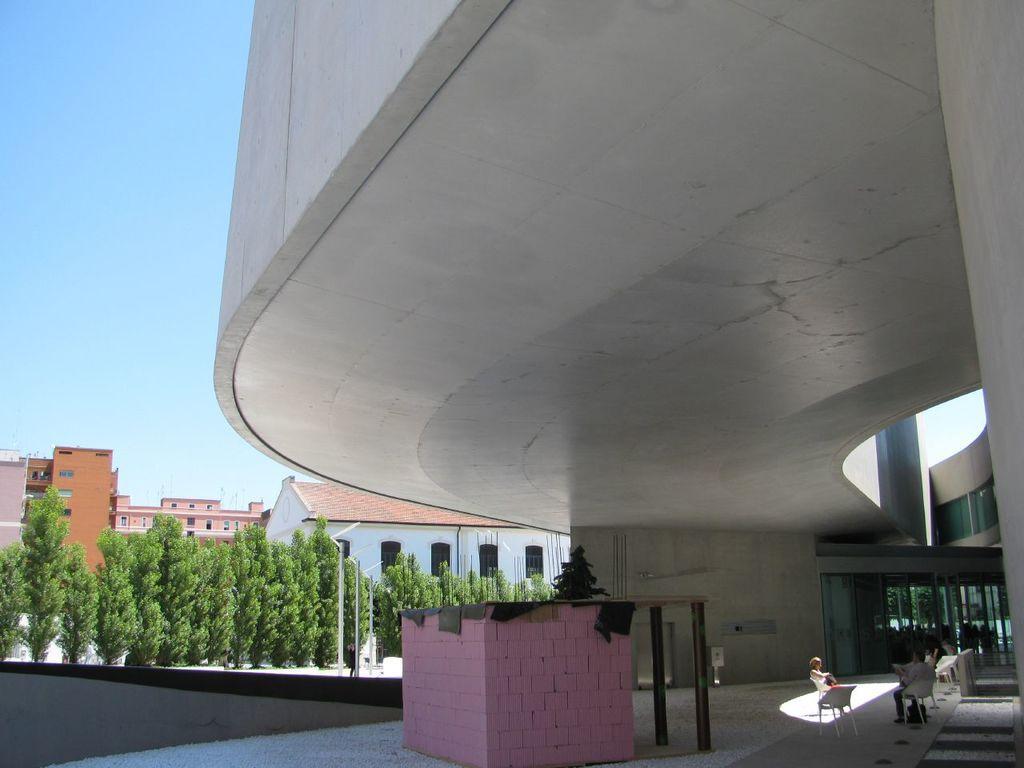Can you describe this image briefly? In this image we can see there are buildings. And we can see the persons sitting on the chair. There is the room and there are clothes, poles and the sky. 